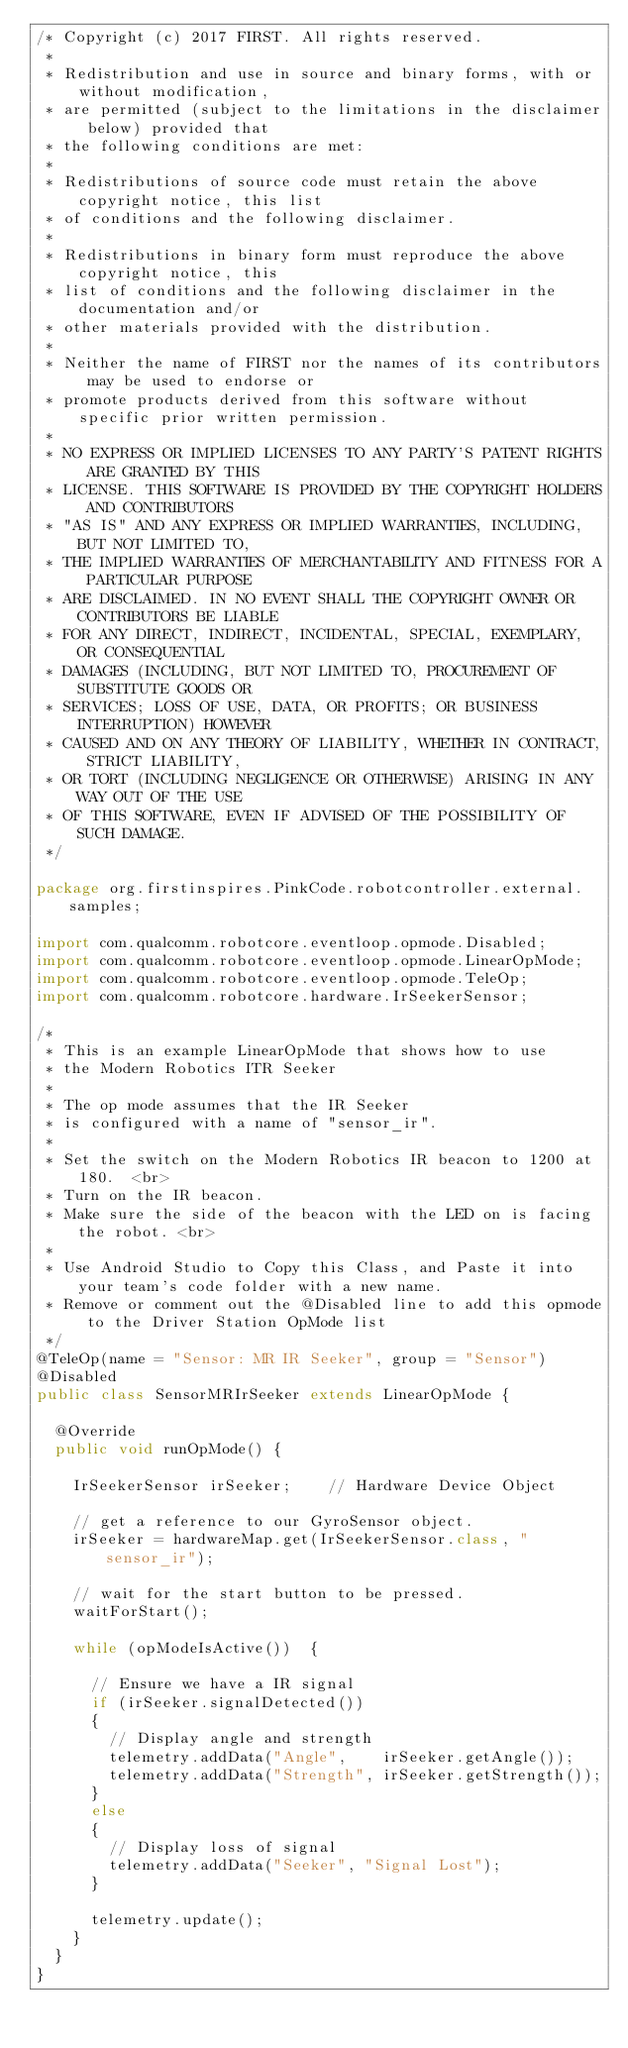<code> <loc_0><loc_0><loc_500><loc_500><_Java_>/* Copyright (c) 2017 FIRST. All rights reserved.
 *
 * Redistribution and use in source and binary forms, with or without modification,
 * are permitted (subject to the limitations in the disclaimer below) provided that
 * the following conditions are met:
 *
 * Redistributions of source code must retain the above copyright notice, this list
 * of conditions and the following disclaimer.
 *
 * Redistributions in binary form must reproduce the above copyright notice, this
 * list of conditions and the following disclaimer in the documentation and/or
 * other materials provided with the distribution.
 *
 * Neither the name of FIRST nor the names of its contributors may be used to endorse or
 * promote products derived from this software without specific prior written permission.
 *
 * NO EXPRESS OR IMPLIED LICENSES TO ANY PARTY'S PATENT RIGHTS ARE GRANTED BY THIS
 * LICENSE. THIS SOFTWARE IS PROVIDED BY THE COPYRIGHT HOLDERS AND CONTRIBUTORS
 * "AS IS" AND ANY EXPRESS OR IMPLIED WARRANTIES, INCLUDING, BUT NOT LIMITED TO,
 * THE IMPLIED WARRANTIES OF MERCHANTABILITY AND FITNESS FOR A PARTICULAR PURPOSE
 * ARE DISCLAIMED. IN NO EVENT SHALL THE COPYRIGHT OWNER OR CONTRIBUTORS BE LIABLE
 * FOR ANY DIRECT, INDIRECT, INCIDENTAL, SPECIAL, EXEMPLARY, OR CONSEQUENTIAL
 * DAMAGES (INCLUDING, BUT NOT LIMITED TO, PROCUREMENT OF SUBSTITUTE GOODS OR
 * SERVICES; LOSS OF USE, DATA, OR PROFITS; OR BUSINESS INTERRUPTION) HOWEVER
 * CAUSED AND ON ANY THEORY OF LIABILITY, WHETHER IN CONTRACT, STRICT LIABILITY,
 * OR TORT (INCLUDING NEGLIGENCE OR OTHERWISE) ARISING IN ANY WAY OUT OF THE USE
 * OF THIS SOFTWARE, EVEN IF ADVISED OF THE POSSIBILITY OF SUCH DAMAGE.
 */

package org.firstinspires.PinkCode.robotcontroller.external.samples;

import com.qualcomm.robotcore.eventloop.opmode.Disabled;
import com.qualcomm.robotcore.eventloop.opmode.LinearOpMode;
import com.qualcomm.robotcore.eventloop.opmode.TeleOp;
import com.qualcomm.robotcore.hardware.IrSeekerSensor;

/*
 * This is an example LinearOpMode that shows how to use
 * the Modern Robotics ITR Seeker
 *
 * The op mode assumes that the IR Seeker
 * is configured with a name of "sensor_ir".
 *
 * Set the switch on the Modern Robotics IR beacon to 1200 at 180.  <br>
 * Turn on the IR beacon.
 * Make sure the side of the beacon with the LED on is facing the robot. <br>
 *
 * Use Android Studio to Copy this Class, and Paste it into your team's code folder with a new name.
 * Remove or comment out the @Disabled line to add this opmode to the Driver Station OpMode list
 */
@TeleOp(name = "Sensor: MR IR Seeker", group = "Sensor")
@Disabled
public class SensorMRIrSeeker extends LinearOpMode {

  @Override
  public void runOpMode() {

    IrSeekerSensor irSeeker;    // Hardware Device Object

    // get a reference to our GyroSensor object.
    irSeeker = hardwareMap.get(IrSeekerSensor.class, "sensor_ir");

    // wait for the start button to be pressed.
    waitForStart();

    while (opModeIsActive())  {

      // Ensure we have a IR signal
      if (irSeeker.signalDetected())
      {
        // Display angle and strength
        telemetry.addData("Angle",    irSeeker.getAngle());
        telemetry.addData("Strength", irSeeker.getStrength());
      }
      else
      {
        // Display loss of signal
        telemetry.addData("Seeker", "Signal Lost");
      }

      telemetry.update();
    }
  }
}
</code> 